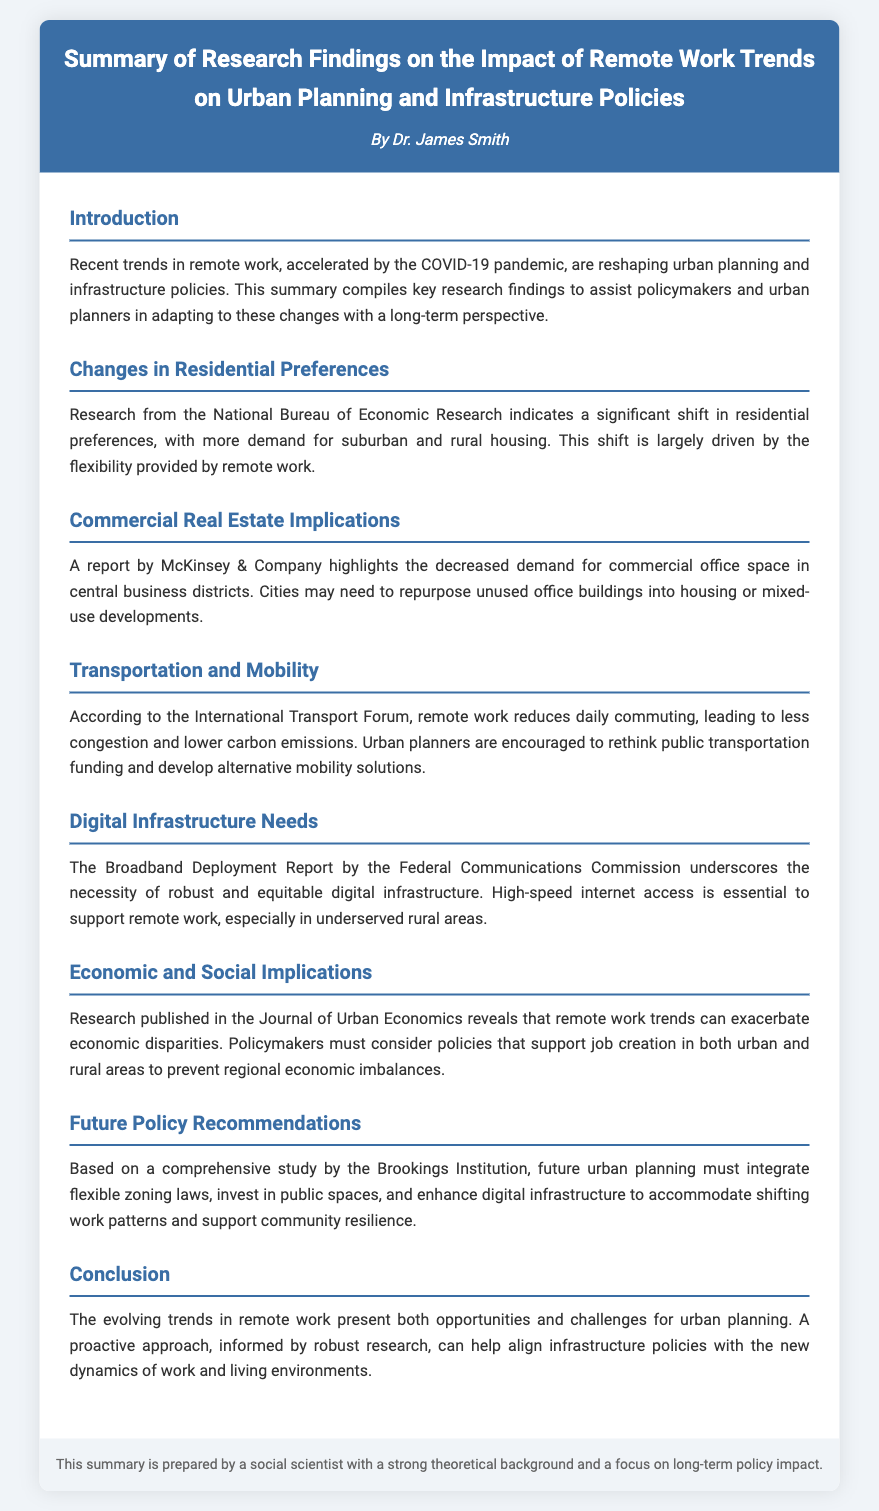What is the title of the research summary? The title is stated at the top of the document under the ticket header.
Answer: Summary of Research Findings on the Impact of Remote Work Trends on Urban Planning and Infrastructure Policies Who authored the research summary? The author's name is provided in the ticket header of the document.
Answer: Dr. James Smith What significant shift in housing demand is mentioned? This information is found in the section about residential preferences, detailing changes in housing demand due to remote work.
Answer: Suburban and rural housing Which organization reported decreased demand for commercial office space? The organization that provided this information is mentioned in the respective section of the document.
Answer: McKinsey & Company What is a recommended future urban planning action? This is found in the section discussing future policy recommendations, indicating what should be done for better urban planning.
Answer: Integrate flexible zoning laws What is one implication of remote work on transportation? This is explained in the section that discusses transportation and mobility, detailing the impact of remote work on daily commuting.
Answer: Less congestion What does the Federal Communications Commission emphasize in their report? This information is found in the section about digital infrastructure needs, focusing on what is essential for remote work.
Answer: Robust and equitable digital infrastructure What issue does the Journal of Urban Economics highlight regarding remote work? This is described in the section discussing economic and social implications and presents concerns that need to be addressed.
Answer: Exacerbate economic disparities What are policymakers encouraged to reconsider due to remote work trends? This is mentioned in the transportation section, offering insights on a necessary change in policy focus.
Answer: Public transportation funding 